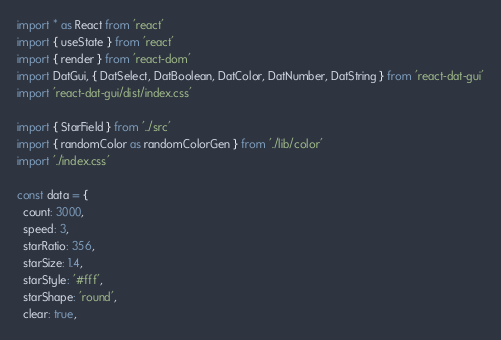Convert code to text. <code><loc_0><loc_0><loc_500><loc_500><_TypeScript_>import * as React from 'react'
import { useState } from 'react'
import { render } from 'react-dom'
import DatGui, { DatSelect, DatBoolean, DatColor, DatNumber, DatString } from 'react-dat-gui'
import 'react-dat-gui/dist/index.css'

import { StarField } from '../src'
import { randomColor as randomColorGen } from './lib/color'
import './index.css'

const data = {
  count: 3000,
  speed: 3,
  starRatio: 356,
  starSize: 1.4,
  starStyle: '#fff',
  starShape: 'round',
  clear: true,</code> 